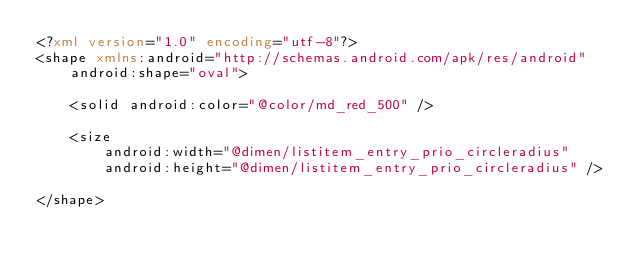<code> <loc_0><loc_0><loc_500><loc_500><_XML_><?xml version="1.0" encoding="utf-8"?>
<shape xmlns:android="http://schemas.android.com/apk/res/android"
    android:shape="oval">

    <solid android:color="@color/md_red_500" />

    <size
        android:width="@dimen/listitem_entry_prio_circleradius"
        android:height="@dimen/listitem_entry_prio_circleradius" />

</shape></code> 